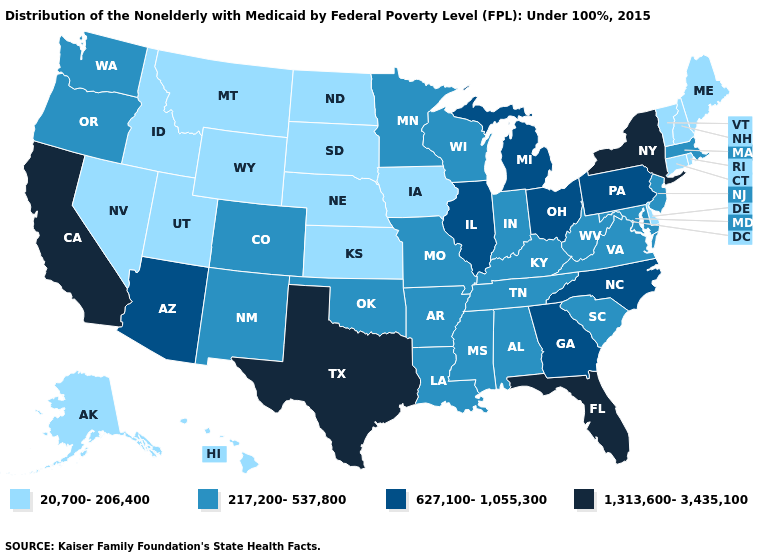What is the value of Maryland?
Concise answer only. 217,200-537,800. Name the states that have a value in the range 217,200-537,800?
Be succinct. Alabama, Arkansas, Colorado, Indiana, Kentucky, Louisiana, Maryland, Massachusetts, Minnesota, Mississippi, Missouri, New Jersey, New Mexico, Oklahoma, Oregon, South Carolina, Tennessee, Virginia, Washington, West Virginia, Wisconsin. Name the states that have a value in the range 627,100-1,055,300?
Concise answer only. Arizona, Georgia, Illinois, Michigan, North Carolina, Ohio, Pennsylvania. What is the value of Louisiana?
Write a very short answer. 217,200-537,800. Which states have the highest value in the USA?
Quick response, please. California, Florida, New York, Texas. Name the states that have a value in the range 217,200-537,800?
Answer briefly. Alabama, Arkansas, Colorado, Indiana, Kentucky, Louisiana, Maryland, Massachusetts, Minnesota, Mississippi, Missouri, New Jersey, New Mexico, Oklahoma, Oregon, South Carolina, Tennessee, Virginia, Washington, West Virginia, Wisconsin. Does Alaska have the same value as North Dakota?
Keep it brief. Yes. Does Wyoming have a higher value than Nebraska?
Quick response, please. No. Name the states that have a value in the range 1,313,600-3,435,100?
Keep it brief. California, Florida, New York, Texas. Name the states that have a value in the range 1,313,600-3,435,100?
Concise answer only. California, Florida, New York, Texas. What is the value of New Hampshire?
Give a very brief answer. 20,700-206,400. Does California have a higher value than New York?
Be succinct. No. Among the states that border Georgia , which have the lowest value?
Short answer required. Alabama, South Carolina, Tennessee. Does Massachusetts have a higher value than Delaware?
Answer briefly. Yes. What is the value of Missouri?
Write a very short answer. 217,200-537,800. 